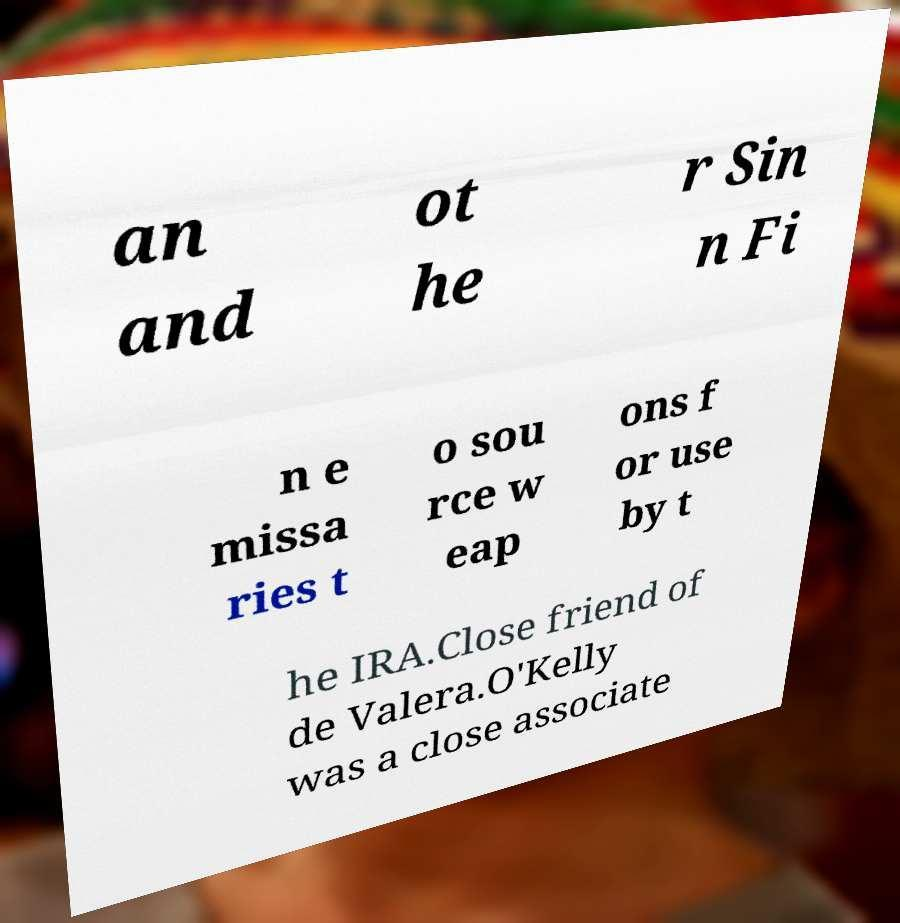Please read and relay the text visible in this image. What does it say? an and ot he r Sin n Fi n e missa ries t o sou rce w eap ons f or use by t he IRA.Close friend of de Valera.O'Kelly was a close associate 